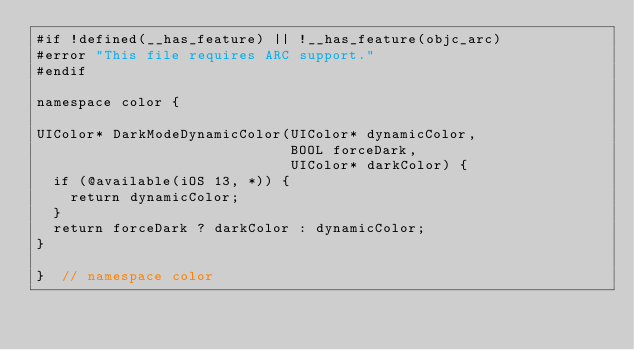Convert code to text. <code><loc_0><loc_0><loc_500><loc_500><_ObjectiveC_>#if !defined(__has_feature) || !__has_feature(objc_arc)
#error "This file requires ARC support."
#endif

namespace color {

UIColor* DarkModeDynamicColor(UIColor* dynamicColor,
                              BOOL forceDark,
                              UIColor* darkColor) {
  if (@available(iOS 13, *)) {
    return dynamicColor;
  }
  return forceDark ? darkColor : dynamicColor;
}

}  // namespace color
</code> 